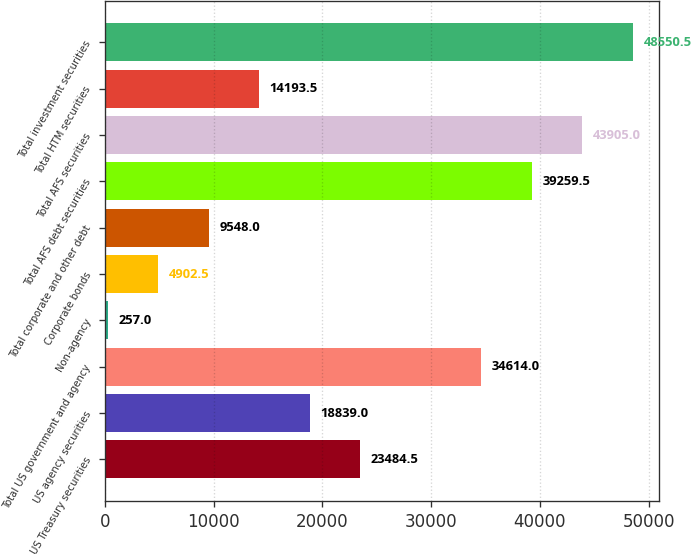Convert chart. <chart><loc_0><loc_0><loc_500><loc_500><bar_chart><fcel>US Treasury securities<fcel>US agency securities<fcel>Total US government and agency<fcel>Non-agency<fcel>Corporate bonds<fcel>Total corporate and other debt<fcel>Total AFS debt securities<fcel>Total AFS securities<fcel>Total HTM securities<fcel>Total investment securities<nl><fcel>23484.5<fcel>18839<fcel>34614<fcel>257<fcel>4902.5<fcel>9548<fcel>39259.5<fcel>43905<fcel>14193.5<fcel>48550.5<nl></chart> 